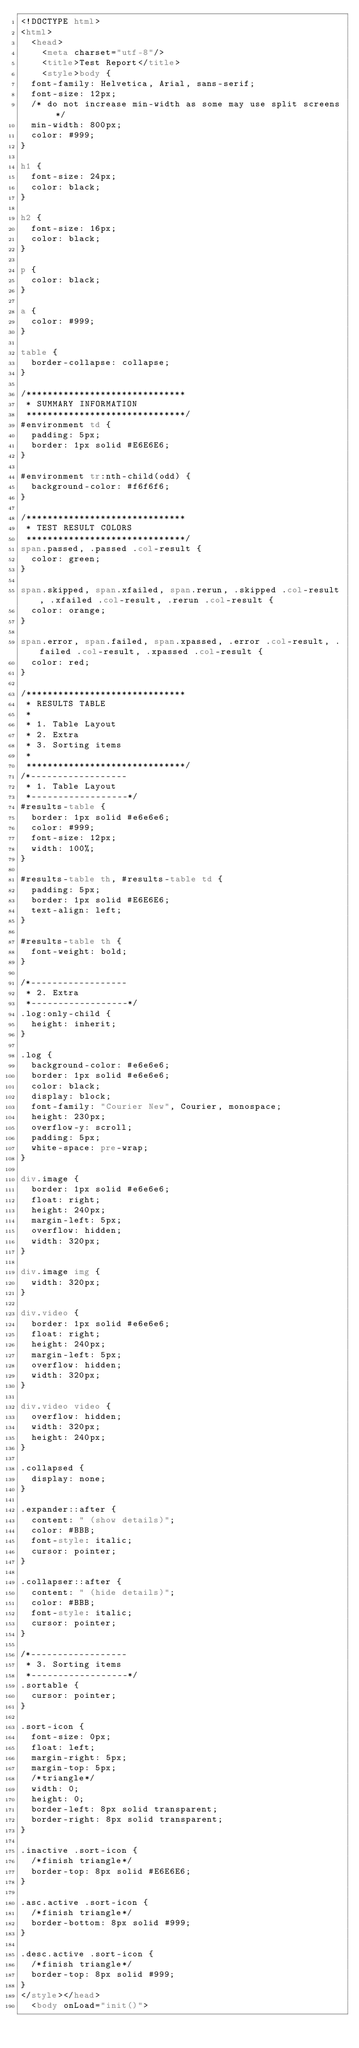<code> <loc_0><loc_0><loc_500><loc_500><_HTML_><!DOCTYPE html>
<html>
  <head>
    <meta charset="utf-8"/>
    <title>Test Report</title>
    <style>body {
  font-family: Helvetica, Arial, sans-serif;
  font-size: 12px;
  /* do not increase min-width as some may use split screens */
  min-width: 800px;
  color: #999;
}

h1 {
  font-size: 24px;
  color: black;
}

h2 {
  font-size: 16px;
  color: black;
}

p {
  color: black;
}

a {
  color: #999;
}

table {
  border-collapse: collapse;
}

/******************************
 * SUMMARY INFORMATION
 ******************************/
#environment td {
  padding: 5px;
  border: 1px solid #E6E6E6;
}

#environment tr:nth-child(odd) {
  background-color: #f6f6f6;
}

/******************************
 * TEST RESULT COLORS
 ******************************/
span.passed, .passed .col-result {
  color: green;
}

span.skipped, span.xfailed, span.rerun, .skipped .col-result, .xfailed .col-result, .rerun .col-result {
  color: orange;
}

span.error, span.failed, span.xpassed, .error .col-result, .failed .col-result, .xpassed .col-result {
  color: red;
}

/******************************
 * RESULTS TABLE
 *
 * 1. Table Layout
 * 2. Extra
 * 3. Sorting items
 *
 ******************************/
/*------------------
 * 1. Table Layout
 *------------------*/
#results-table {
  border: 1px solid #e6e6e6;
  color: #999;
  font-size: 12px;
  width: 100%;
}

#results-table th, #results-table td {
  padding: 5px;
  border: 1px solid #E6E6E6;
  text-align: left;
}

#results-table th {
  font-weight: bold;
}

/*------------------
 * 2. Extra
 *------------------*/
.log:only-child {
  height: inherit;
}

.log {
  background-color: #e6e6e6;
  border: 1px solid #e6e6e6;
  color: black;
  display: block;
  font-family: "Courier New", Courier, monospace;
  height: 230px;
  overflow-y: scroll;
  padding: 5px;
  white-space: pre-wrap;
}

div.image {
  border: 1px solid #e6e6e6;
  float: right;
  height: 240px;
  margin-left: 5px;
  overflow: hidden;
  width: 320px;
}

div.image img {
  width: 320px;
}

div.video {
  border: 1px solid #e6e6e6;
  float: right;
  height: 240px;
  margin-left: 5px;
  overflow: hidden;
  width: 320px;
}

div.video video {
  overflow: hidden;
  width: 320px;
  height: 240px;
}

.collapsed {
  display: none;
}

.expander::after {
  content: " (show details)";
  color: #BBB;
  font-style: italic;
  cursor: pointer;
}

.collapser::after {
  content: " (hide details)";
  color: #BBB;
  font-style: italic;
  cursor: pointer;
}

/*------------------
 * 3. Sorting items
 *------------------*/
.sortable {
  cursor: pointer;
}

.sort-icon {
  font-size: 0px;
  float: left;
  margin-right: 5px;
  margin-top: 5px;
  /*triangle*/
  width: 0;
  height: 0;
  border-left: 8px solid transparent;
  border-right: 8px solid transparent;
}

.inactive .sort-icon {
  /*finish triangle*/
  border-top: 8px solid #E6E6E6;
}

.asc.active .sort-icon {
  /*finish triangle*/
  border-bottom: 8px solid #999;
}

.desc.active .sort-icon {
  /*finish triangle*/
  border-top: 8px solid #999;
}
</style></head>
  <body onLoad="init()"></code> 